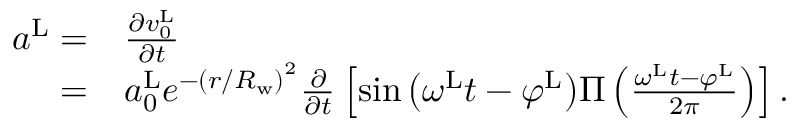<formula> <loc_0><loc_0><loc_500><loc_500>\begin{array} { r l } { a ^ { L } = } & { \frac { \partial v _ { 0 } ^ { L } } { \partial t } } \\ { = } & { a _ { 0 } ^ { L } e ^ { - { ( { r / R _ { w } } ) } ^ { 2 } } \frac { \partial } { \partial t } \left [ { \sin \left ( { \omega ^ { L } t - \varphi ^ { L } } \right ) } \Pi \left ( \frac { \omega ^ { L } t - \varphi ^ { L } } { 2 \pi } \right ) \right ] . } \end{array}</formula> 